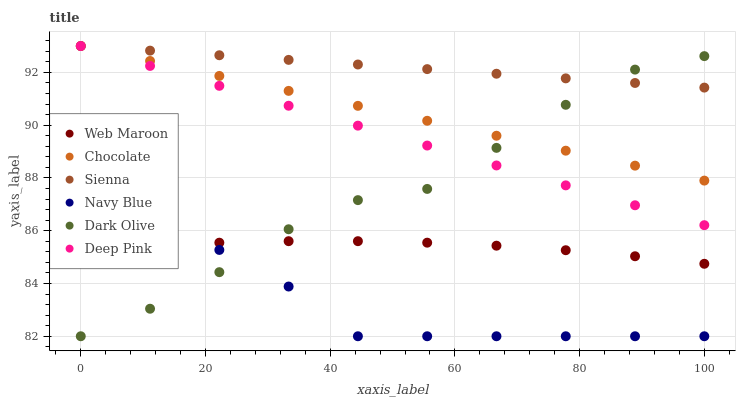Does Navy Blue have the minimum area under the curve?
Answer yes or no. Yes. Does Sienna have the maximum area under the curve?
Answer yes or no. Yes. Does Dark Olive have the minimum area under the curve?
Answer yes or no. No. Does Dark Olive have the maximum area under the curve?
Answer yes or no. No. Is Deep Pink the smoothest?
Answer yes or no. Yes. Is Dark Olive the roughest?
Answer yes or no. Yes. Is Navy Blue the smoothest?
Answer yes or no. No. Is Navy Blue the roughest?
Answer yes or no. No. Does Navy Blue have the lowest value?
Answer yes or no. Yes. Does Web Maroon have the lowest value?
Answer yes or no. No. Does Sienna have the highest value?
Answer yes or no. Yes. Does Navy Blue have the highest value?
Answer yes or no. No. Is Navy Blue less than Chocolate?
Answer yes or no. Yes. Is Deep Pink greater than Web Maroon?
Answer yes or no. Yes. Does Dark Olive intersect Sienna?
Answer yes or no. Yes. Is Dark Olive less than Sienna?
Answer yes or no. No. Is Dark Olive greater than Sienna?
Answer yes or no. No. Does Navy Blue intersect Chocolate?
Answer yes or no. No. 